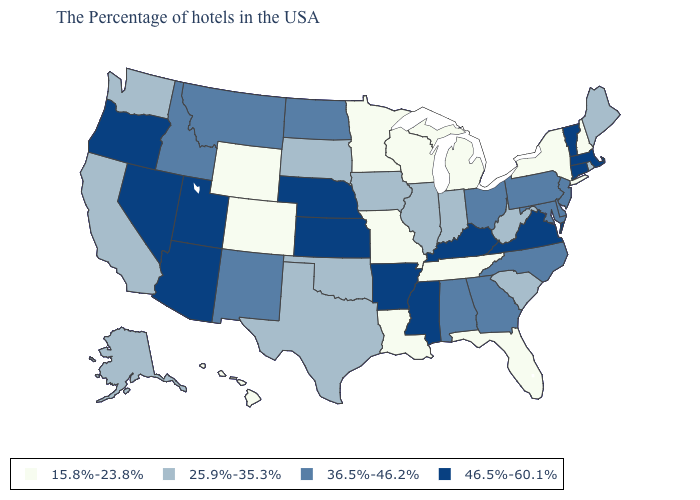Does Washington have the lowest value in the West?
Answer briefly. No. What is the highest value in the USA?
Write a very short answer. 46.5%-60.1%. Which states have the highest value in the USA?
Give a very brief answer. Massachusetts, Vermont, Connecticut, Virginia, Kentucky, Mississippi, Arkansas, Kansas, Nebraska, Utah, Arizona, Nevada, Oregon. What is the value of Texas?
Answer briefly. 25.9%-35.3%. Does Connecticut have the lowest value in the USA?
Short answer required. No. Name the states that have a value in the range 15.8%-23.8%?
Answer briefly. New Hampshire, New York, Florida, Michigan, Tennessee, Wisconsin, Louisiana, Missouri, Minnesota, Wyoming, Colorado, Hawaii. Does Michigan have the lowest value in the USA?
Concise answer only. Yes. How many symbols are there in the legend?
Give a very brief answer. 4. Which states have the lowest value in the Northeast?
Be succinct. New Hampshire, New York. Does California have a lower value than Delaware?
Short answer required. Yes. Which states have the highest value in the USA?
Be succinct. Massachusetts, Vermont, Connecticut, Virginia, Kentucky, Mississippi, Arkansas, Kansas, Nebraska, Utah, Arizona, Nevada, Oregon. Name the states that have a value in the range 36.5%-46.2%?
Concise answer only. New Jersey, Delaware, Maryland, Pennsylvania, North Carolina, Ohio, Georgia, Alabama, North Dakota, New Mexico, Montana, Idaho. Which states have the lowest value in the Northeast?
Write a very short answer. New Hampshire, New York. What is the lowest value in the South?
Quick response, please. 15.8%-23.8%. Does the first symbol in the legend represent the smallest category?
Be succinct. Yes. 